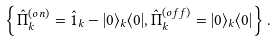Convert formula to latex. <formula><loc_0><loc_0><loc_500><loc_500>\left \{ \hat { \Pi } ^ { ( o n ) } _ { k } = \hat { 1 } _ { k } - | 0 \rangle _ { k } \langle 0 | , \hat { \Pi } ^ { ( o f f ) } _ { k } = | 0 \rangle _ { k } \langle 0 | \right \} .</formula> 